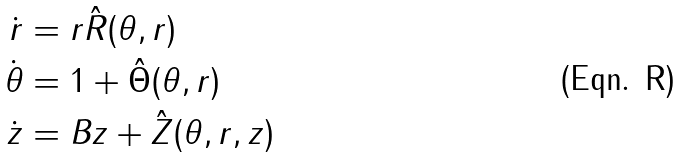Convert formula to latex. <formula><loc_0><loc_0><loc_500><loc_500>\dot { r } & = r \hat { R } ( \theta , r ) \\ \dot { \theta } & = 1 + \hat { \Theta } ( \theta , r ) \\ \dot { z } & = B z + \hat { Z } ( \theta , r , z )</formula> 